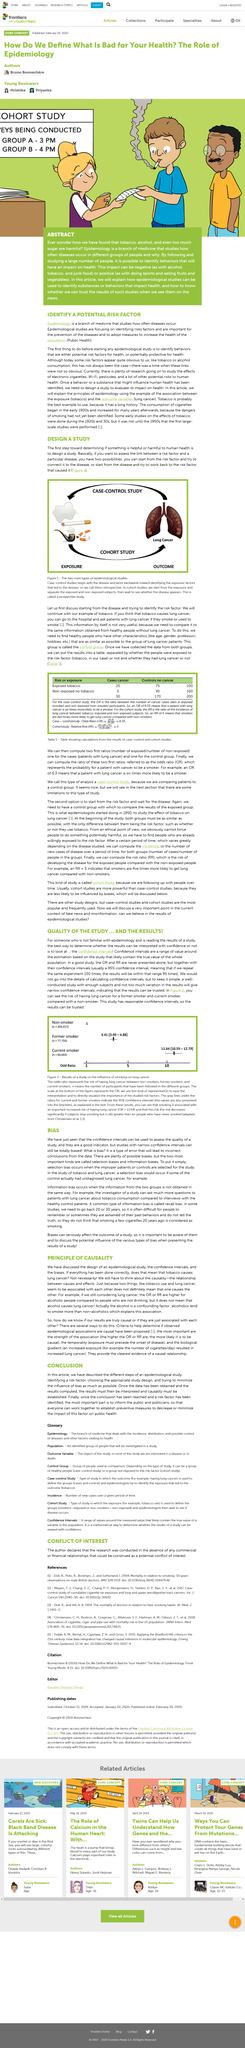List a handful of essential elements in this visual. A case-control study is a type of analysis that compares individuals who have a particular disease or outcome of interest (the cases) to a group of individuals who do not have the disease or outcome (the controls) in order to determine potential risk factors or causal associations. The caption for the picture states "The two main types of epidemiological studies are presented in the image. The likelihood that a patient with lung cancer is a smoker is six times higher than that of a non-smoker. Epidemiological studies can be categorized into two main types: case-control studies and cohort studies. Case-control studies involve identifying a group of individuals who have the disease of interest (the cases) and comparing them to a group of individuals who do not have the disease (the controls) in order to identify potential risk factors for the disease. Cohort studies involve following a group of individuals over time who have not yet developed the disease of interest in order to identify risk factors and evaluate the progression of the disease. Figure 2 shows the odds ratio for the relationship between exposure to air pollution and the incidence of asthma. 